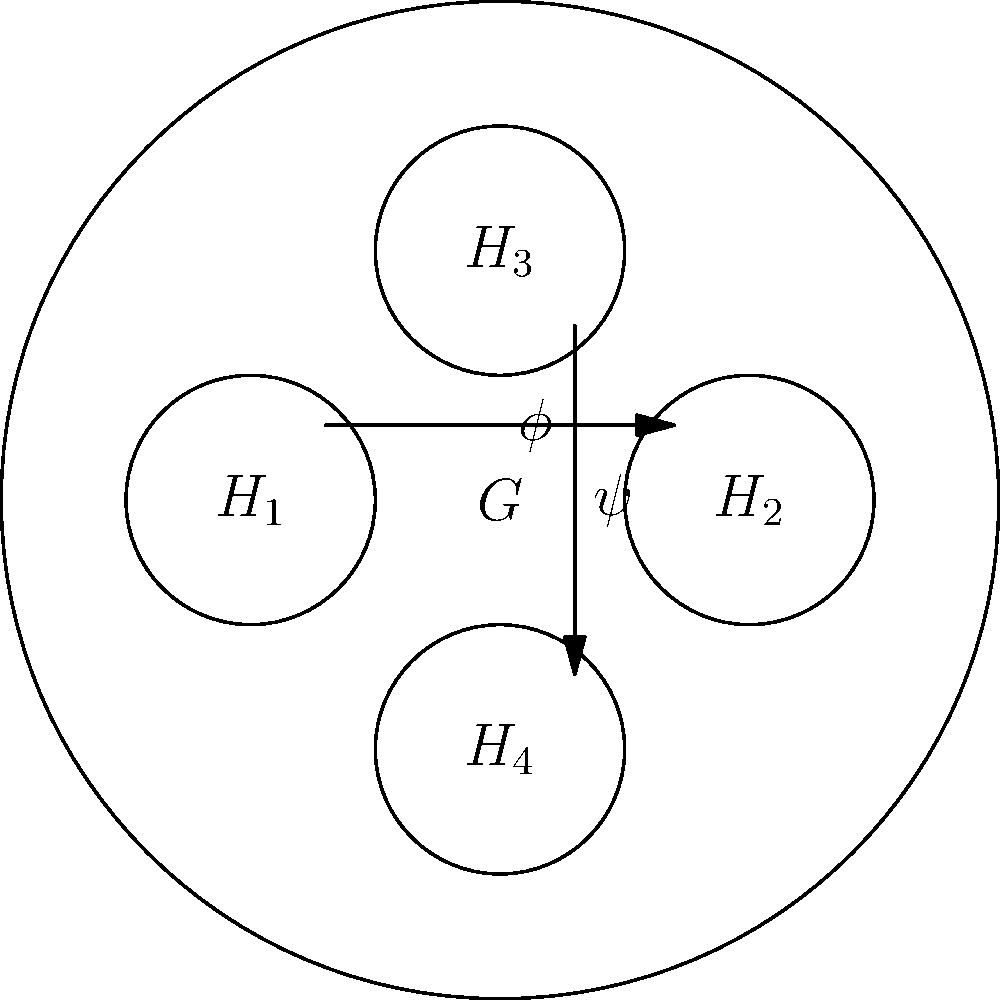In the group diagram above, $G$ represents a larger group with subgroups $H_1$, $H_2$, $H_3$, and $H_4$. Given that $\phi$ and $\psi$ are isomorphisms between subgroups, identify all pairs of isomorphic subgroups within $G$. To identify isomorphic subgroups, we need to analyze the given isomorphisms and their relationships:

1. The arrow labeled $\phi$ indicates an isomorphism between $H_1$ and $H_2$.
2. The arrow labeled $\psi$ indicates an isomorphism between $H_3$ and $H_4$.

From these observations, we can conclude:

a) $H_1 \cong H_2$ (isomorphic) due to the isomorphism $\phi$.
b) $H_3 \cong H_4$ (isomorphic) due to the isomorphism $\psi$.

There are no other explicitly shown isomorphisms between the subgroups. Therefore, we cannot conclude any other isomorphisms without additional information.

In the context of drug discovery and neural network analysis, identifying isomorphic subgroups can be analogous to finding similar structural patterns in molecular graphs or equivalent subnetworks in neural architectures, which could be valuable for predicting drug interactions or optimizing network designs.
Answer: $(H_1, H_2)$ and $(H_3, H_4)$ 